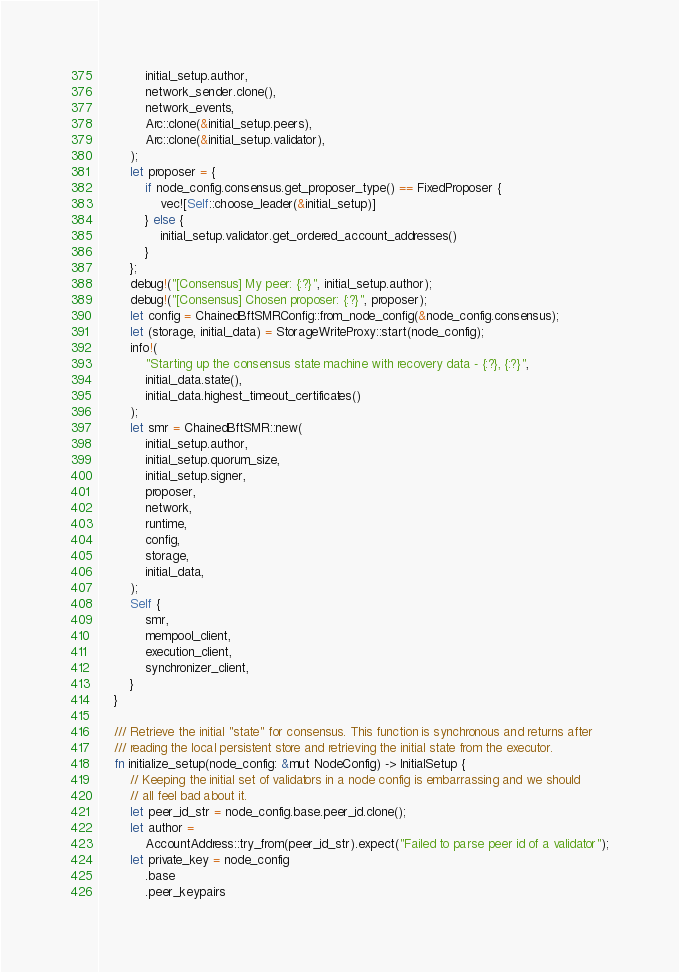Convert code to text. <code><loc_0><loc_0><loc_500><loc_500><_Rust_>            initial_setup.author,
            network_sender.clone(),
            network_events,
            Arc::clone(&initial_setup.peers),
            Arc::clone(&initial_setup.validator),
        );
        let proposer = {
            if node_config.consensus.get_proposer_type() == FixedProposer {
                vec![Self::choose_leader(&initial_setup)]
            } else {
                initial_setup.validator.get_ordered_account_addresses()
            }
        };
        debug!("[Consensus] My peer: {:?}", initial_setup.author);
        debug!("[Consensus] Chosen proposer: {:?}", proposer);
        let config = ChainedBftSMRConfig::from_node_config(&node_config.consensus);
        let (storage, initial_data) = StorageWriteProxy::start(node_config);
        info!(
            "Starting up the consensus state machine with recovery data - {:?}, {:?}",
            initial_data.state(),
            initial_data.highest_timeout_certificates()
        );
        let smr = ChainedBftSMR::new(
            initial_setup.author,
            initial_setup.quorum_size,
            initial_setup.signer,
            proposer,
            network,
            runtime,
            config,
            storage,
            initial_data,
        );
        Self {
            smr,
            mempool_client,
            execution_client,
            synchronizer_client,
        }
    }

    /// Retrieve the initial "state" for consensus. This function is synchronous and returns after
    /// reading the local persistent store and retrieving the initial state from the executor.
    fn initialize_setup(node_config: &mut NodeConfig) -> InitialSetup {
        // Keeping the initial set of validators in a node config is embarrassing and we should
        // all feel bad about it.
        let peer_id_str = node_config.base.peer_id.clone();
        let author =
            AccountAddress::try_from(peer_id_str).expect("Failed to parse peer id of a validator");
        let private_key = node_config
            .base
            .peer_keypairs</code> 